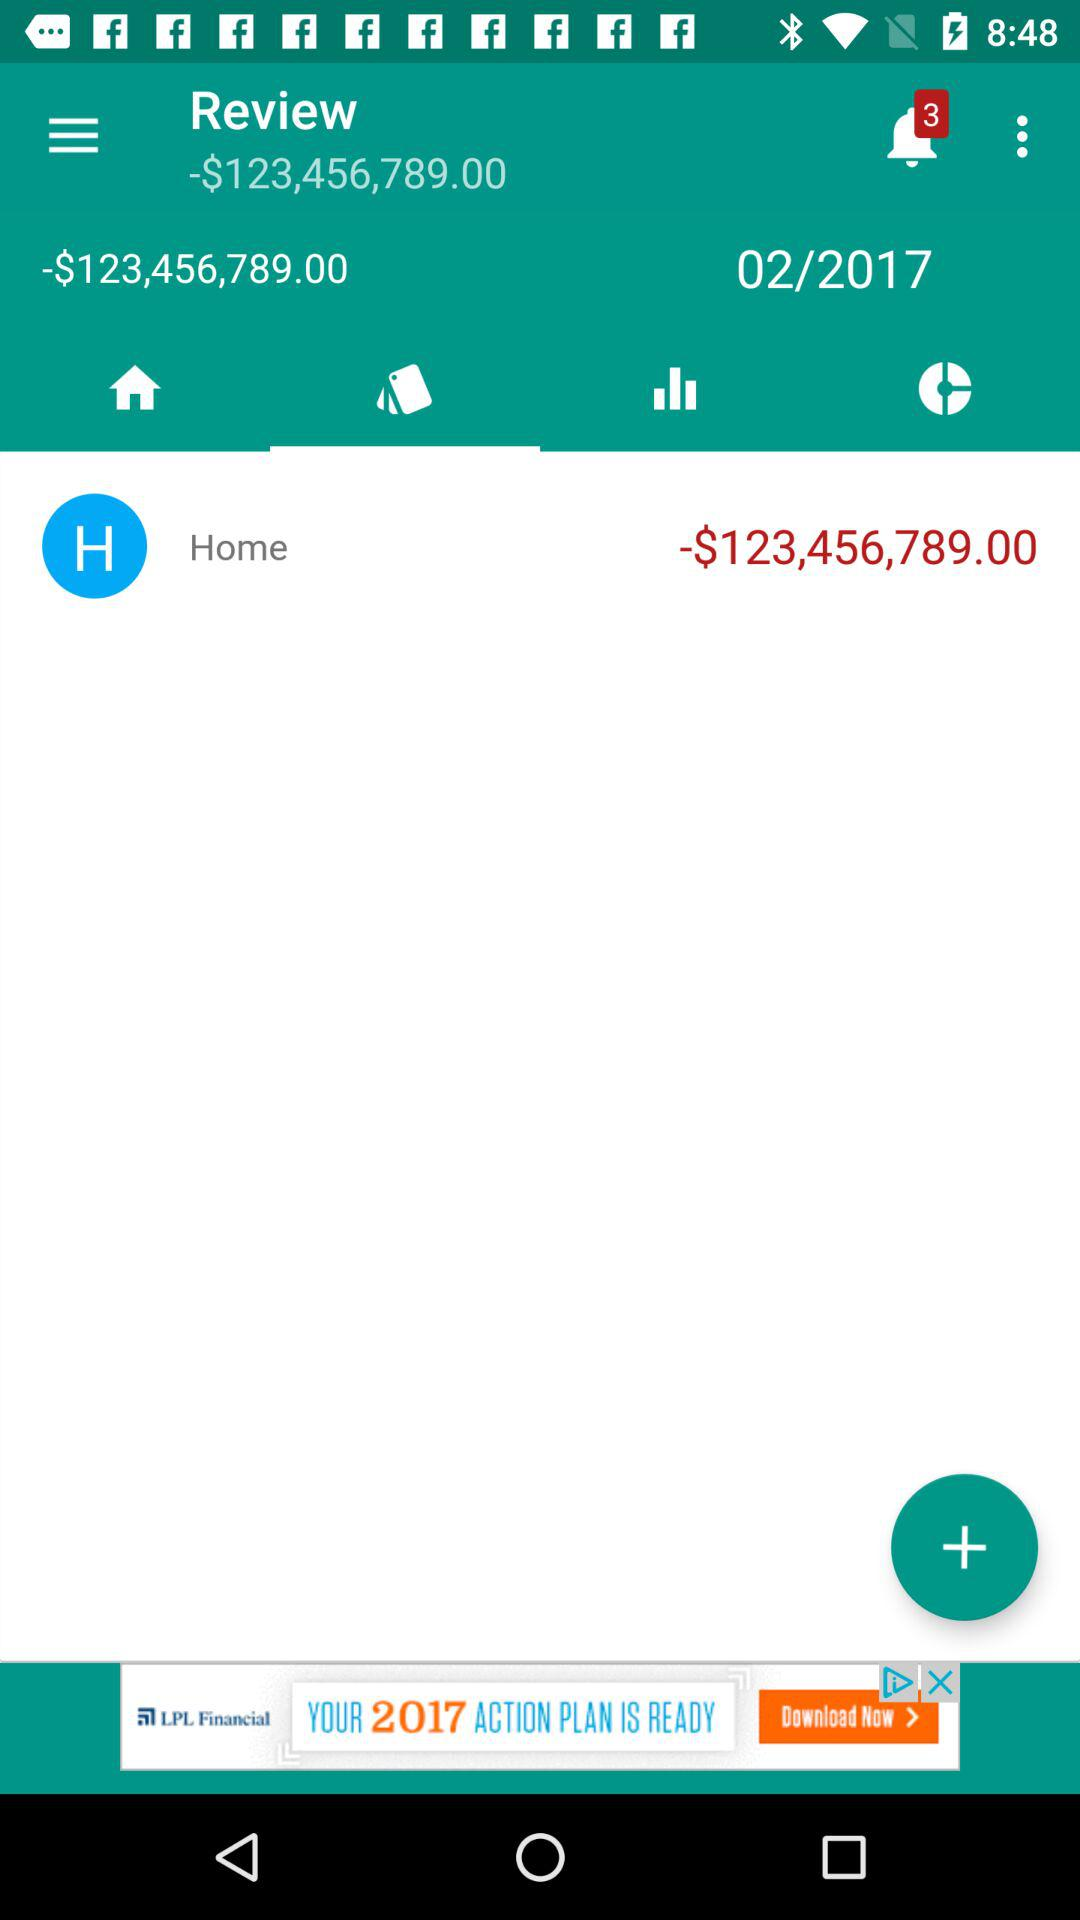How many unread notifications are there? There are 3 unread notifications. 